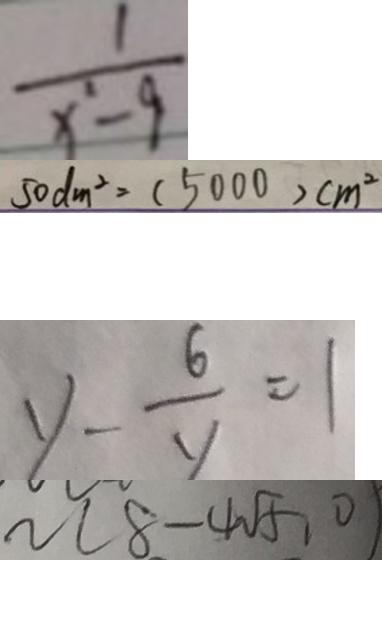<formula> <loc_0><loc_0><loc_500><loc_500>\frac { 1 } { x ^ { 2 } - 9 } 
 5 0 d m ^ { 2 } = ( 5 0 0 0 ) c m ^ { 2 } 
 y - \frac { 6 } { y } = 1 
 n ( 8 - 4 \sqrt { 5 } , 0 )</formula> 